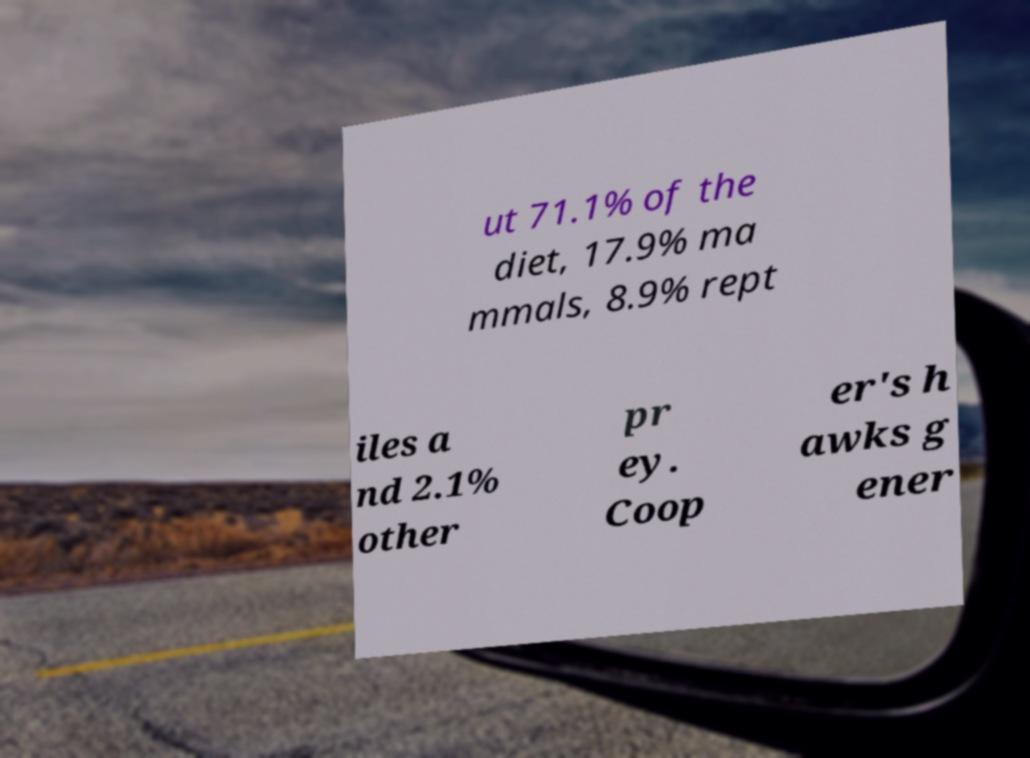There's text embedded in this image that I need extracted. Can you transcribe it verbatim? ut 71.1% of the diet, 17.9% ma mmals, 8.9% rept iles a nd 2.1% other pr ey. Coop er's h awks g ener 